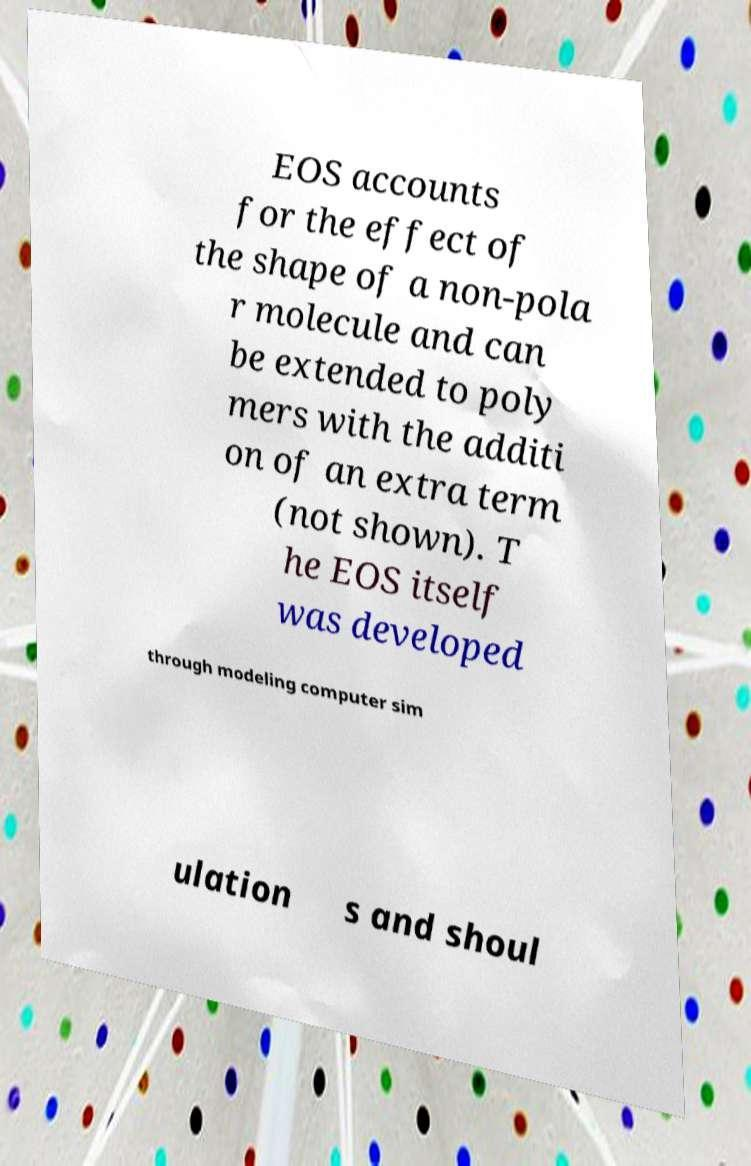I need the written content from this picture converted into text. Can you do that? EOS accounts for the effect of the shape of a non-pola r molecule and can be extended to poly mers with the additi on of an extra term (not shown). T he EOS itself was developed through modeling computer sim ulation s and shoul 